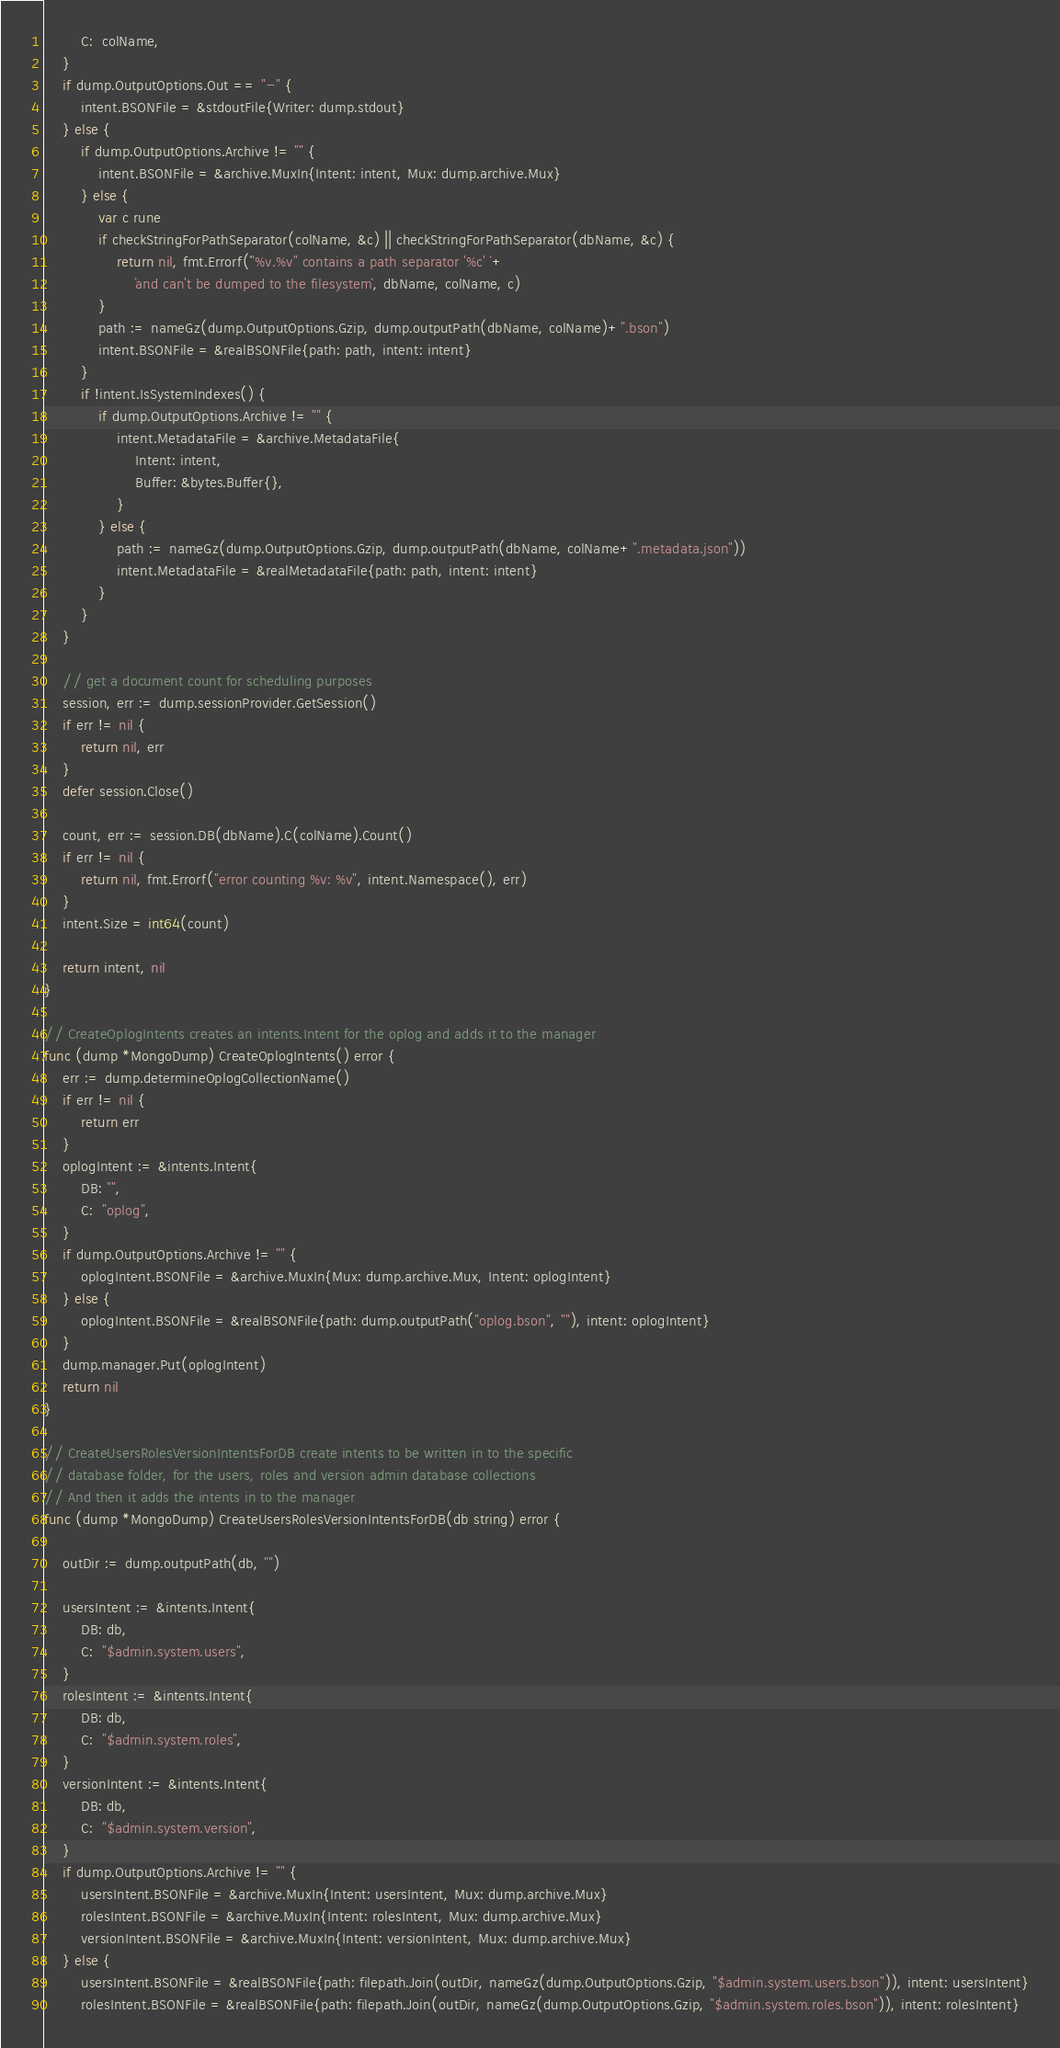<code> <loc_0><loc_0><loc_500><loc_500><_Go_>		C:  colName,
	}
	if dump.OutputOptions.Out == "-" {
		intent.BSONFile = &stdoutFile{Writer: dump.stdout}
	} else {
		if dump.OutputOptions.Archive != "" {
			intent.BSONFile = &archive.MuxIn{Intent: intent, Mux: dump.archive.Mux}
		} else {
			var c rune
			if checkStringForPathSeparator(colName, &c) || checkStringForPathSeparator(dbName, &c) {
				return nil, fmt.Errorf(`"%v.%v" contains a path separator '%c' `+
					`and can't be dumped to the filesystem`, dbName, colName, c)
			}
			path := nameGz(dump.OutputOptions.Gzip, dump.outputPath(dbName, colName)+".bson")
			intent.BSONFile = &realBSONFile{path: path, intent: intent}
		}
		if !intent.IsSystemIndexes() {
			if dump.OutputOptions.Archive != "" {
				intent.MetadataFile = &archive.MetadataFile{
					Intent: intent,
					Buffer: &bytes.Buffer{},
				}
			} else {
				path := nameGz(dump.OutputOptions.Gzip, dump.outputPath(dbName, colName+".metadata.json"))
				intent.MetadataFile = &realMetadataFile{path: path, intent: intent}
			}
		}
	}

	// get a document count for scheduling purposes
	session, err := dump.sessionProvider.GetSession()
	if err != nil {
		return nil, err
	}
	defer session.Close()

	count, err := session.DB(dbName).C(colName).Count()
	if err != nil {
		return nil, fmt.Errorf("error counting %v: %v", intent.Namespace(), err)
	}
	intent.Size = int64(count)

	return intent, nil
}

// CreateOplogIntents creates an intents.Intent for the oplog and adds it to the manager
func (dump *MongoDump) CreateOplogIntents() error {
	err := dump.determineOplogCollectionName()
	if err != nil {
		return err
	}
	oplogIntent := &intents.Intent{
		DB: "",
		C:  "oplog",
	}
	if dump.OutputOptions.Archive != "" {
		oplogIntent.BSONFile = &archive.MuxIn{Mux: dump.archive.Mux, Intent: oplogIntent}
	} else {
		oplogIntent.BSONFile = &realBSONFile{path: dump.outputPath("oplog.bson", ""), intent: oplogIntent}
	}
	dump.manager.Put(oplogIntent)
	return nil
}

// CreateUsersRolesVersionIntentsForDB create intents to be written in to the specific
// database folder, for the users, roles and version admin database collections
// And then it adds the intents in to the manager
func (dump *MongoDump) CreateUsersRolesVersionIntentsForDB(db string) error {

	outDir := dump.outputPath(db, "")

	usersIntent := &intents.Intent{
		DB: db,
		C:  "$admin.system.users",
	}
	rolesIntent := &intents.Intent{
		DB: db,
		C:  "$admin.system.roles",
	}
	versionIntent := &intents.Intent{
		DB: db,
		C:  "$admin.system.version",
	}
	if dump.OutputOptions.Archive != "" {
		usersIntent.BSONFile = &archive.MuxIn{Intent: usersIntent, Mux: dump.archive.Mux}
		rolesIntent.BSONFile = &archive.MuxIn{Intent: rolesIntent, Mux: dump.archive.Mux}
		versionIntent.BSONFile = &archive.MuxIn{Intent: versionIntent, Mux: dump.archive.Mux}
	} else {
		usersIntent.BSONFile = &realBSONFile{path: filepath.Join(outDir, nameGz(dump.OutputOptions.Gzip, "$admin.system.users.bson")), intent: usersIntent}
		rolesIntent.BSONFile = &realBSONFile{path: filepath.Join(outDir, nameGz(dump.OutputOptions.Gzip, "$admin.system.roles.bson")), intent: rolesIntent}</code> 